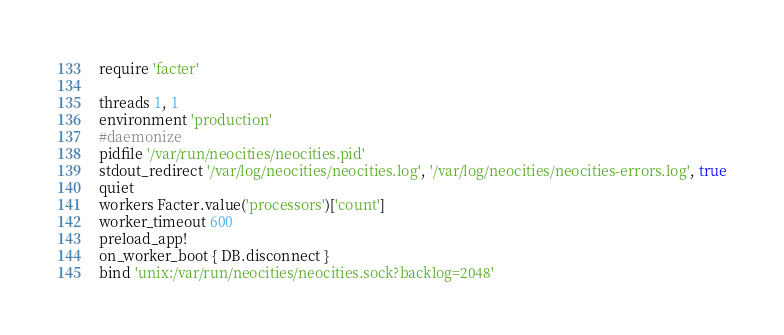<code> <loc_0><loc_0><loc_500><loc_500><_Ruby_>require 'facter'

threads 1, 1
environment 'production'
#daemonize
pidfile '/var/run/neocities/neocities.pid'
stdout_redirect '/var/log/neocities/neocities.log', '/var/log/neocities/neocities-errors.log', true
quiet
workers Facter.value('processors')['count']
worker_timeout 600
preload_app!
on_worker_boot { DB.disconnect }
bind 'unix:/var/run/neocities/neocities.sock?backlog=2048'
</code> 